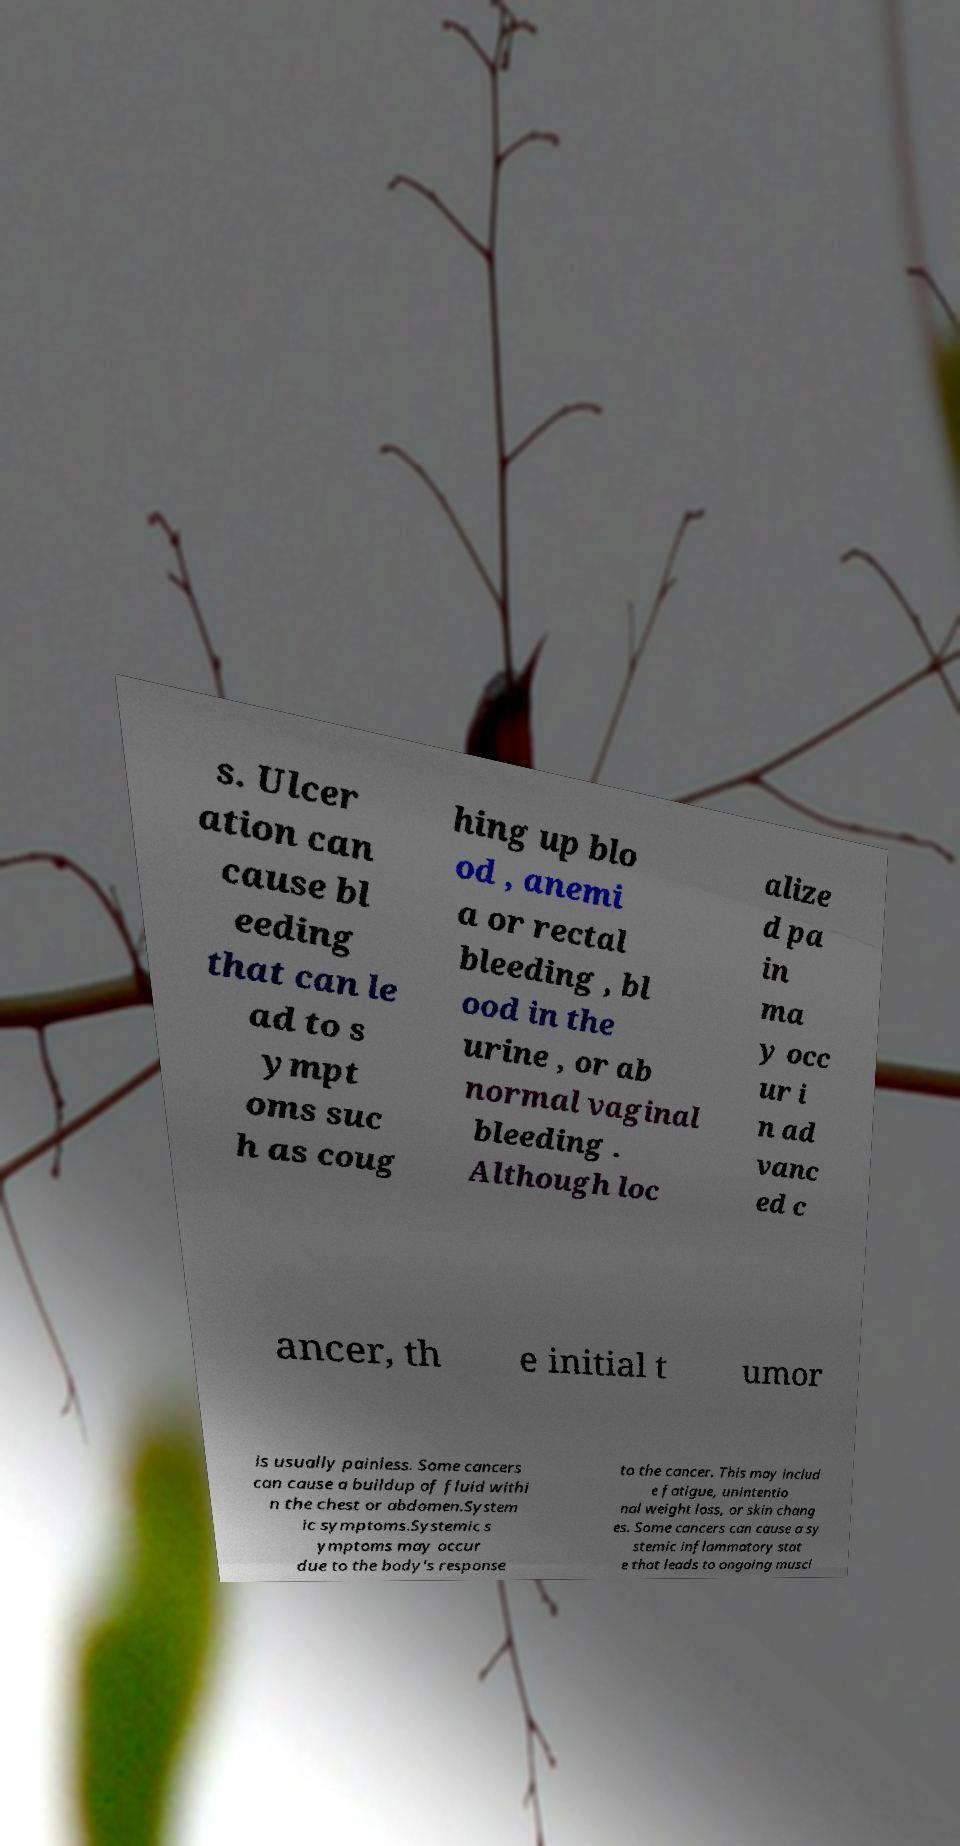Could you assist in decoding the text presented in this image and type it out clearly? s. Ulcer ation can cause bl eeding that can le ad to s ympt oms suc h as coug hing up blo od , anemi a or rectal bleeding , bl ood in the urine , or ab normal vaginal bleeding . Although loc alize d pa in ma y occ ur i n ad vanc ed c ancer, th e initial t umor is usually painless. Some cancers can cause a buildup of fluid withi n the chest or abdomen.System ic symptoms.Systemic s ymptoms may occur due to the body's response to the cancer. This may includ e fatigue, unintentio nal weight loss, or skin chang es. Some cancers can cause a sy stemic inflammatory stat e that leads to ongoing muscl 